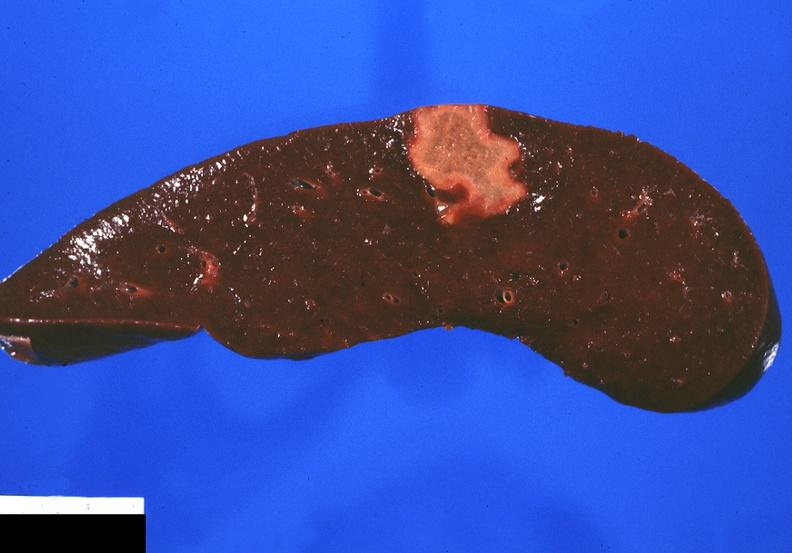where is this part in?
Answer the question using a single word or phrase. Spleen 